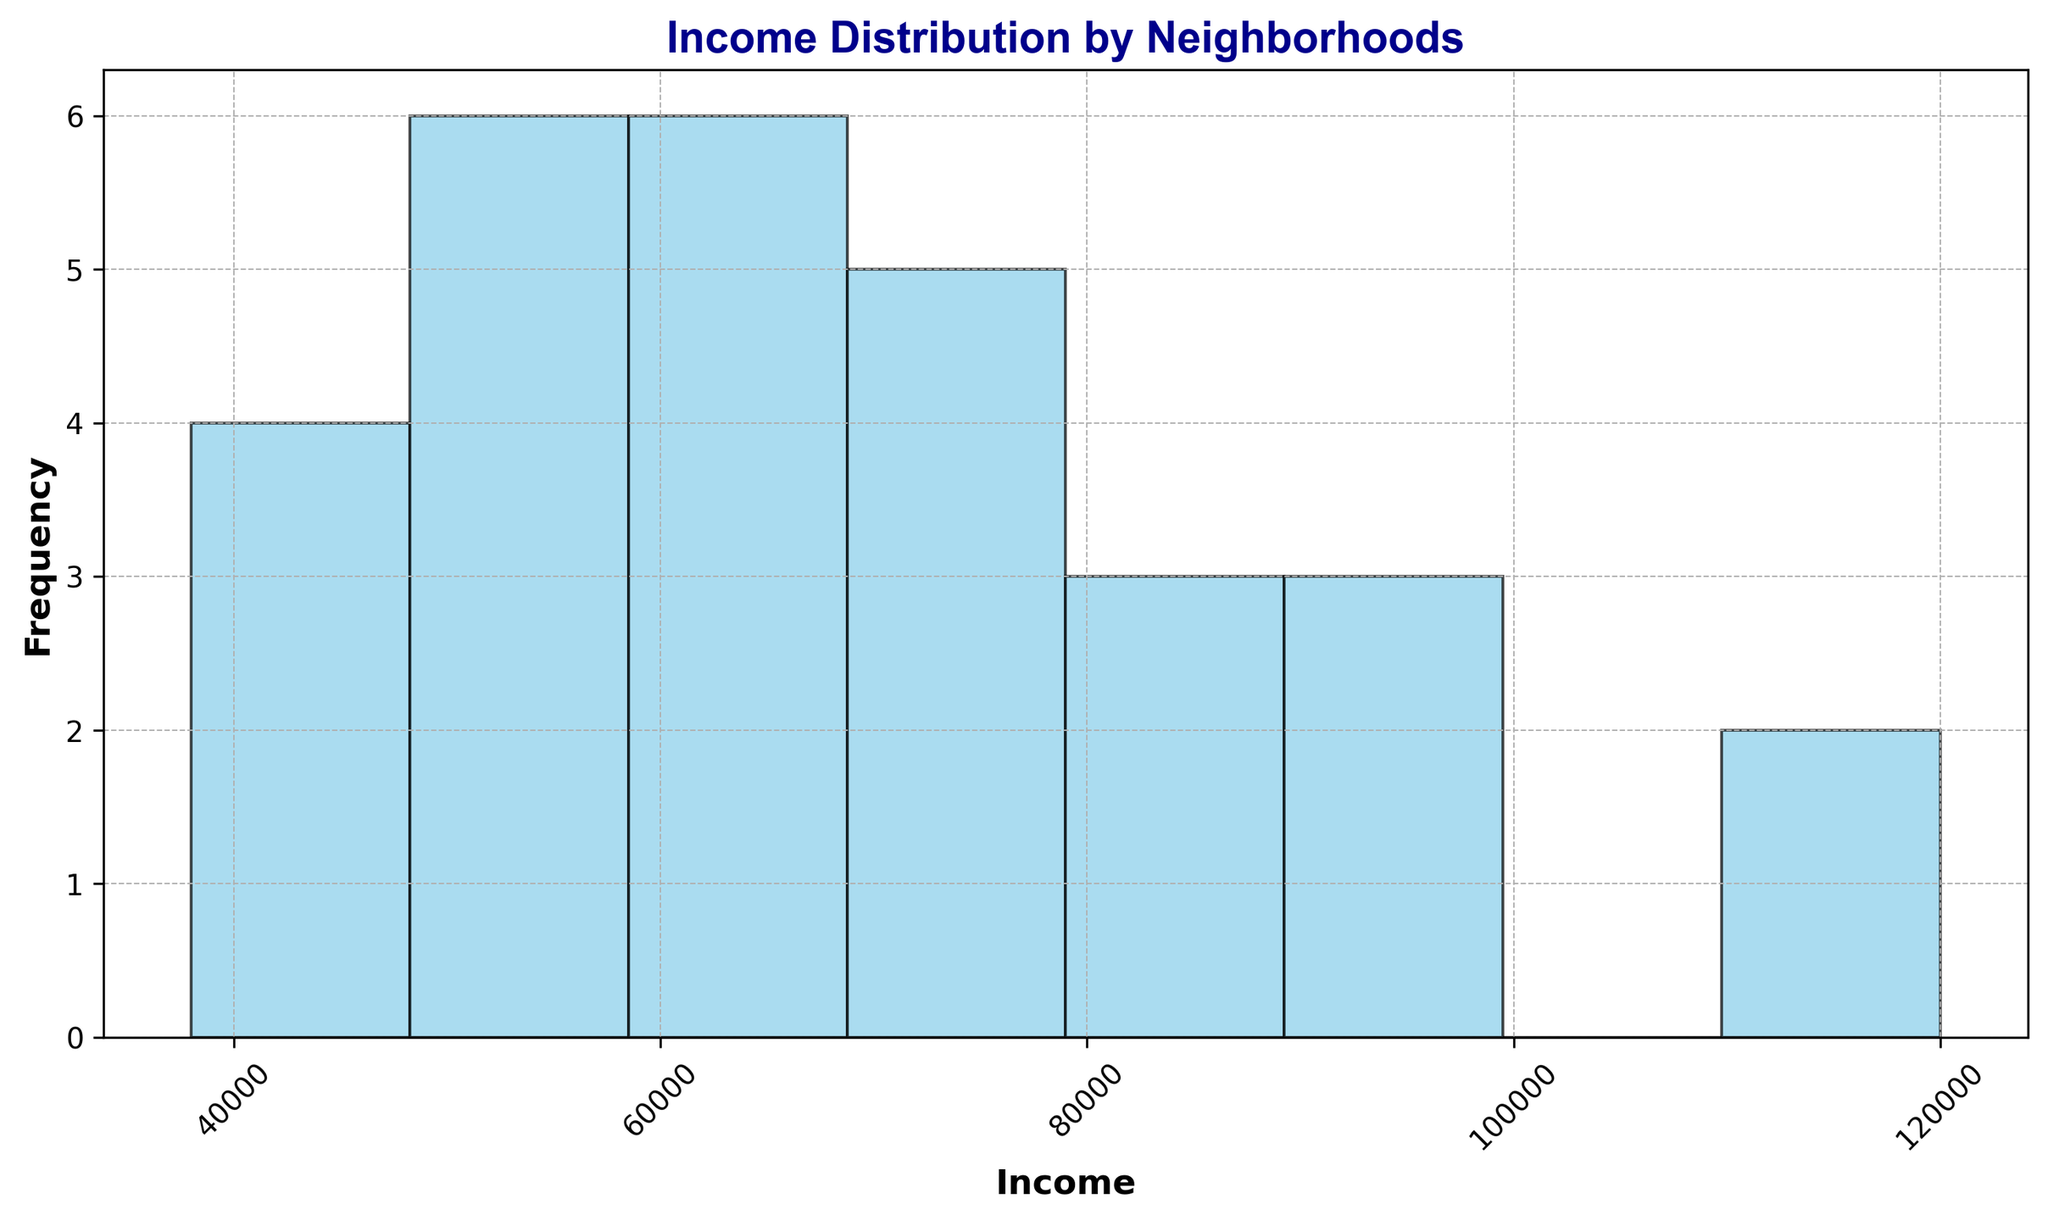What is the most common income range among the neighborhoods? By analyzing the histogram, identify the income bin that has the highest bar length, which indicates the highest frequency.
Answer: $70,000 - $80,000 How many neighborhoods fall into the $50,000 - $60,000 income range? Look at the height of the bar that represents the $50,000 - $60,000 range to determine the frequency.
Answer: 3 neighborhoods Which neighborhood has the highest income, and what is that income? Identify the highest value in the dataset and match it to the corresponding neighborhood.
Answer: Financial District, $120,000 What is the range of incomes displayed on the x-axis? Observe the minimum and maximum income values on the x-axis of the histogram.
Answer: $38,000 - $120,000 Are there more neighborhoods in the $80,000 - $90,000 income range or the $40,000 - $50,000 income range? Compare the heights of the bars representing these two income ranges to determine which is taller.
Answer: $80,000 - $90,000 What is the median income range for the neighborhoods in this city? To find the median income range, list all neighborhoods' incomes in ascending order and find the middle value or range it falls into. There are 30 data points, so the median is between the 15th and 16th values.
Answer: $62,000 - $70,000 How many neighborhoods exceed an income of $90,000? Count the number of bars and their corresponding neighborhoods where the income is greater than $90,000.
Answer: 3 neighborhoods Is the income distribution skewed towards higher or lower income ranges? Observe the shape of the histogram; if there are more bars (frequencies) on the lower end versus higher end, it's skewed accordingly.
Answer: Lower income ranges 